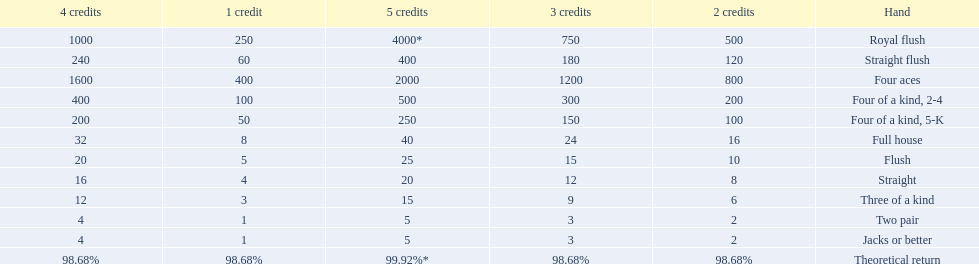What are the hands in super aces? Royal flush, Straight flush, Four aces, Four of a kind, 2-4, Four of a kind, 5-K, Full house, Flush, Straight, Three of a kind, Two pair, Jacks or better. What hand gives the highest credits? Royal flush. 